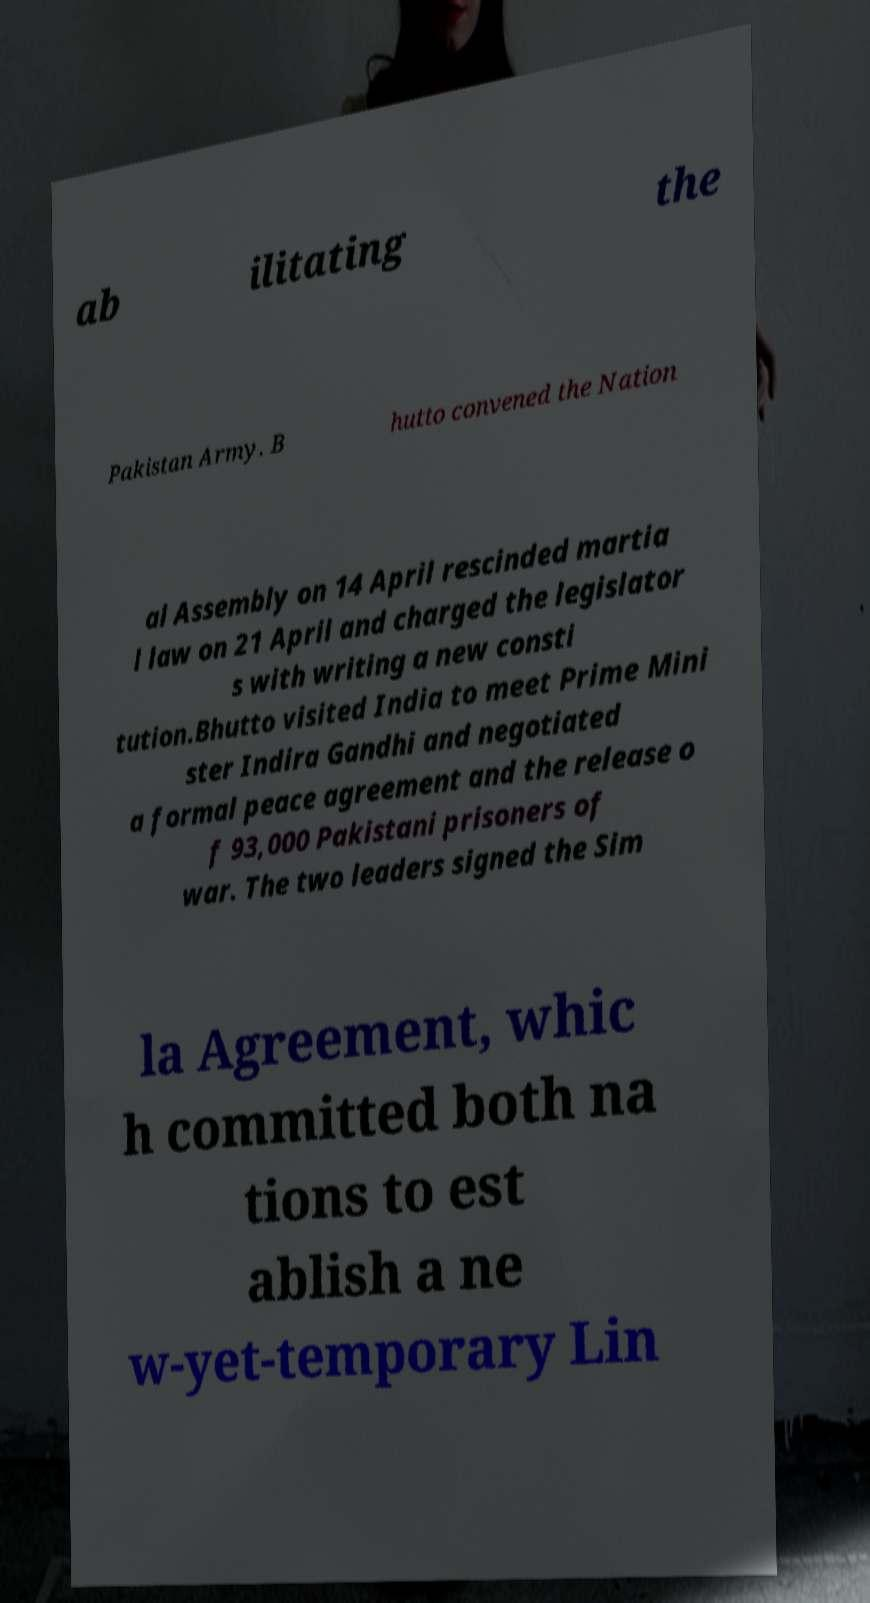What messages or text are displayed in this image? I need them in a readable, typed format. ab ilitating the Pakistan Army. B hutto convened the Nation al Assembly on 14 April rescinded martia l law on 21 April and charged the legislator s with writing a new consti tution.Bhutto visited India to meet Prime Mini ster Indira Gandhi and negotiated a formal peace agreement and the release o f 93,000 Pakistani prisoners of war. The two leaders signed the Sim la Agreement, whic h committed both na tions to est ablish a ne w-yet-temporary Lin 